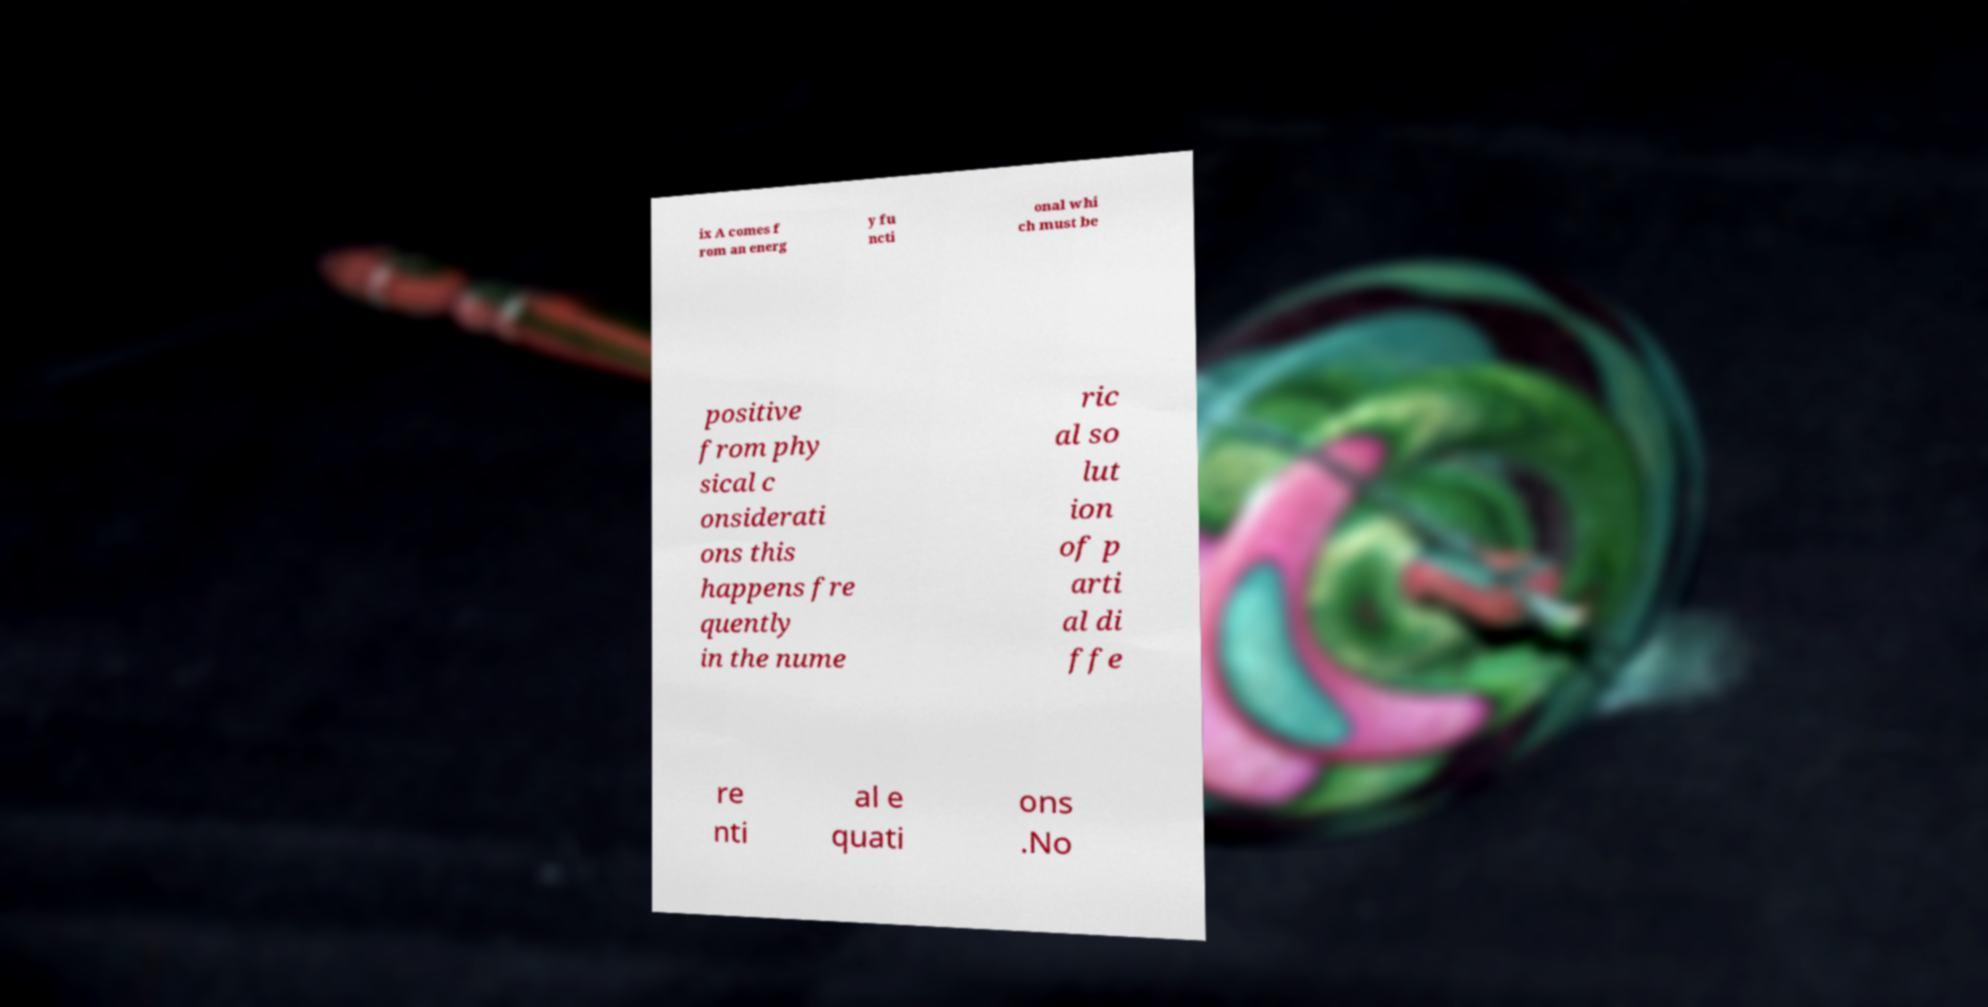For documentation purposes, I need the text within this image transcribed. Could you provide that? ix A comes f rom an energ y fu ncti onal whi ch must be positive from phy sical c onsiderati ons this happens fre quently in the nume ric al so lut ion of p arti al di ffe re nti al e quati ons .No 